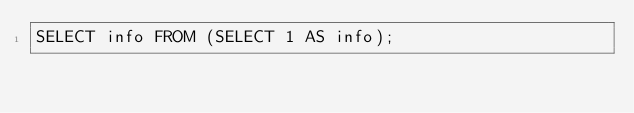<code> <loc_0><loc_0><loc_500><loc_500><_SQL_>SELECT info FROM (SELECT 1 AS info);
</code> 